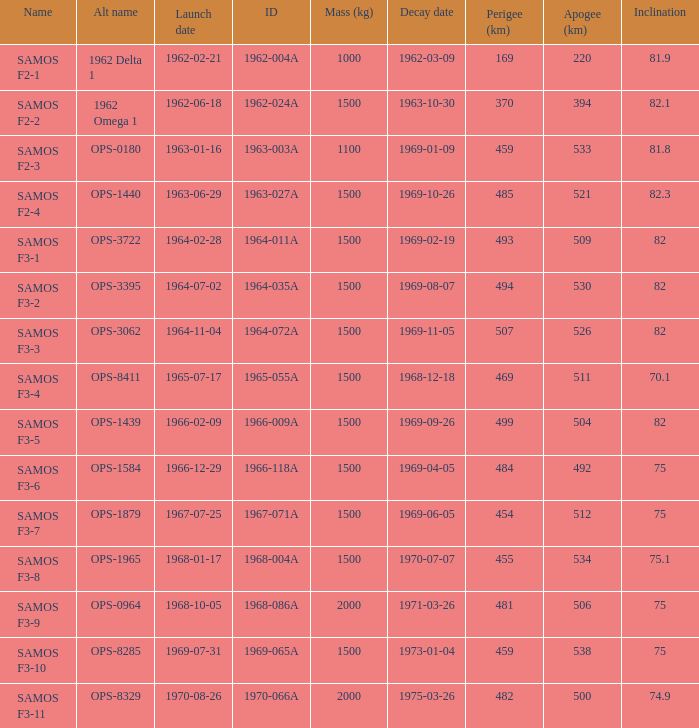What is the maximum apogee for samos f3-3? 526.0. 